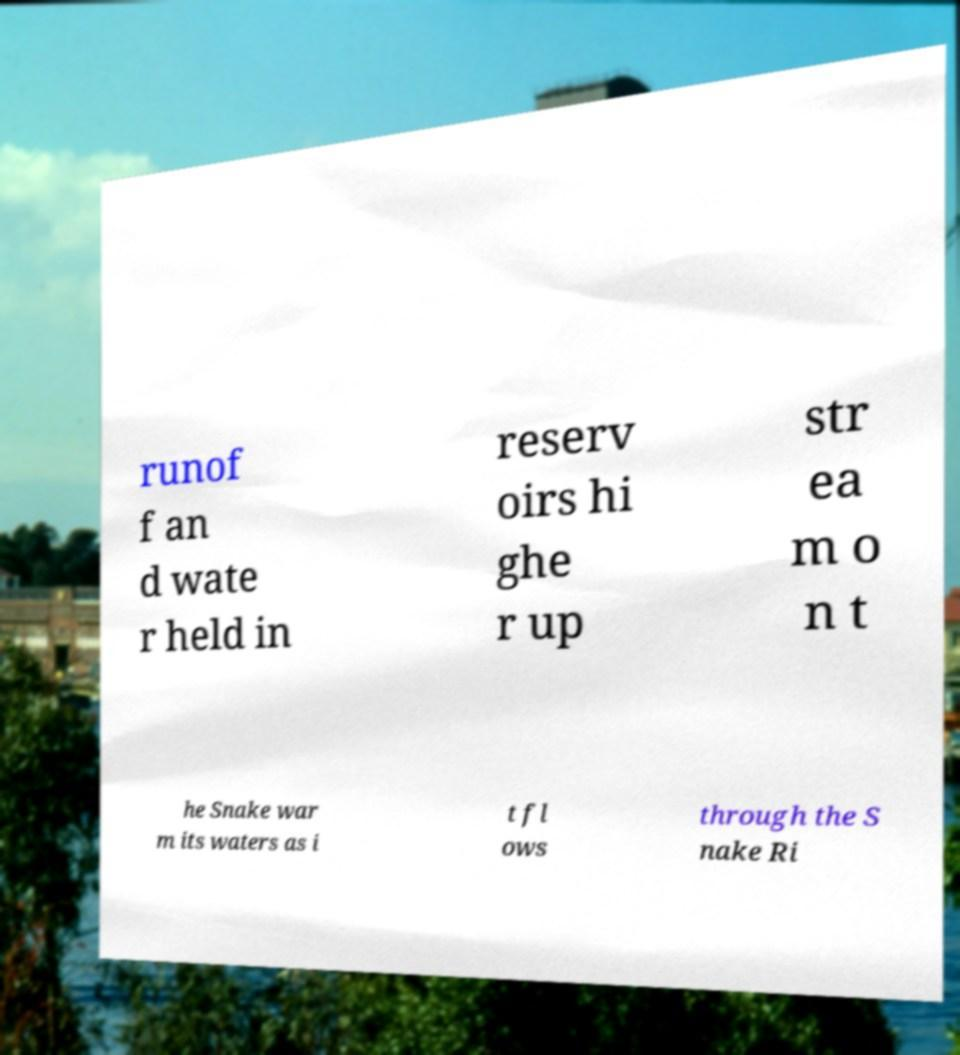What messages or text are displayed in this image? I need them in a readable, typed format. runof f an d wate r held in reserv oirs hi ghe r up str ea m o n t he Snake war m its waters as i t fl ows through the S nake Ri 